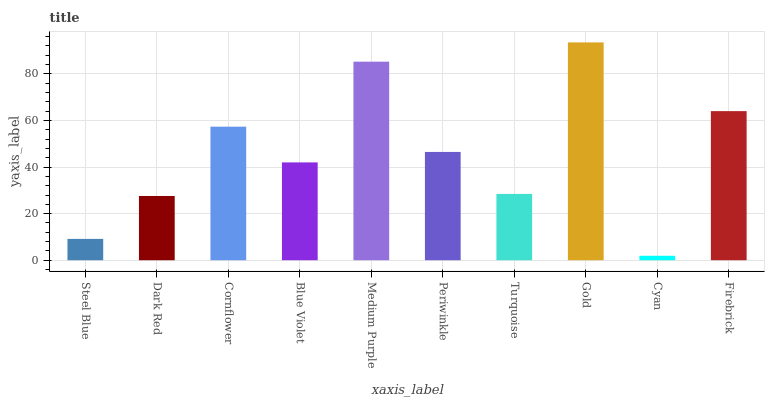Is Dark Red the minimum?
Answer yes or no. No. Is Dark Red the maximum?
Answer yes or no. No. Is Dark Red greater than Steel Blue?
Answer yes or no. Yes. Is Steel Blue less than Dark Red?
Answer yes or no. Yes. Is Steel Blue greater than Dark Red?
Answer yes or no. No. Is Dark Red less than Steel Blue?
Answer yes or no. No. Is Periwinkle the high median?
Answer yes or no. Yes. Is Blue Violet the low median?
Answer yes or no. Yes. Is Cyan the high median?
Answer yes or no. No. Is Periwinkle the low median?
Answer yes or no. No. 